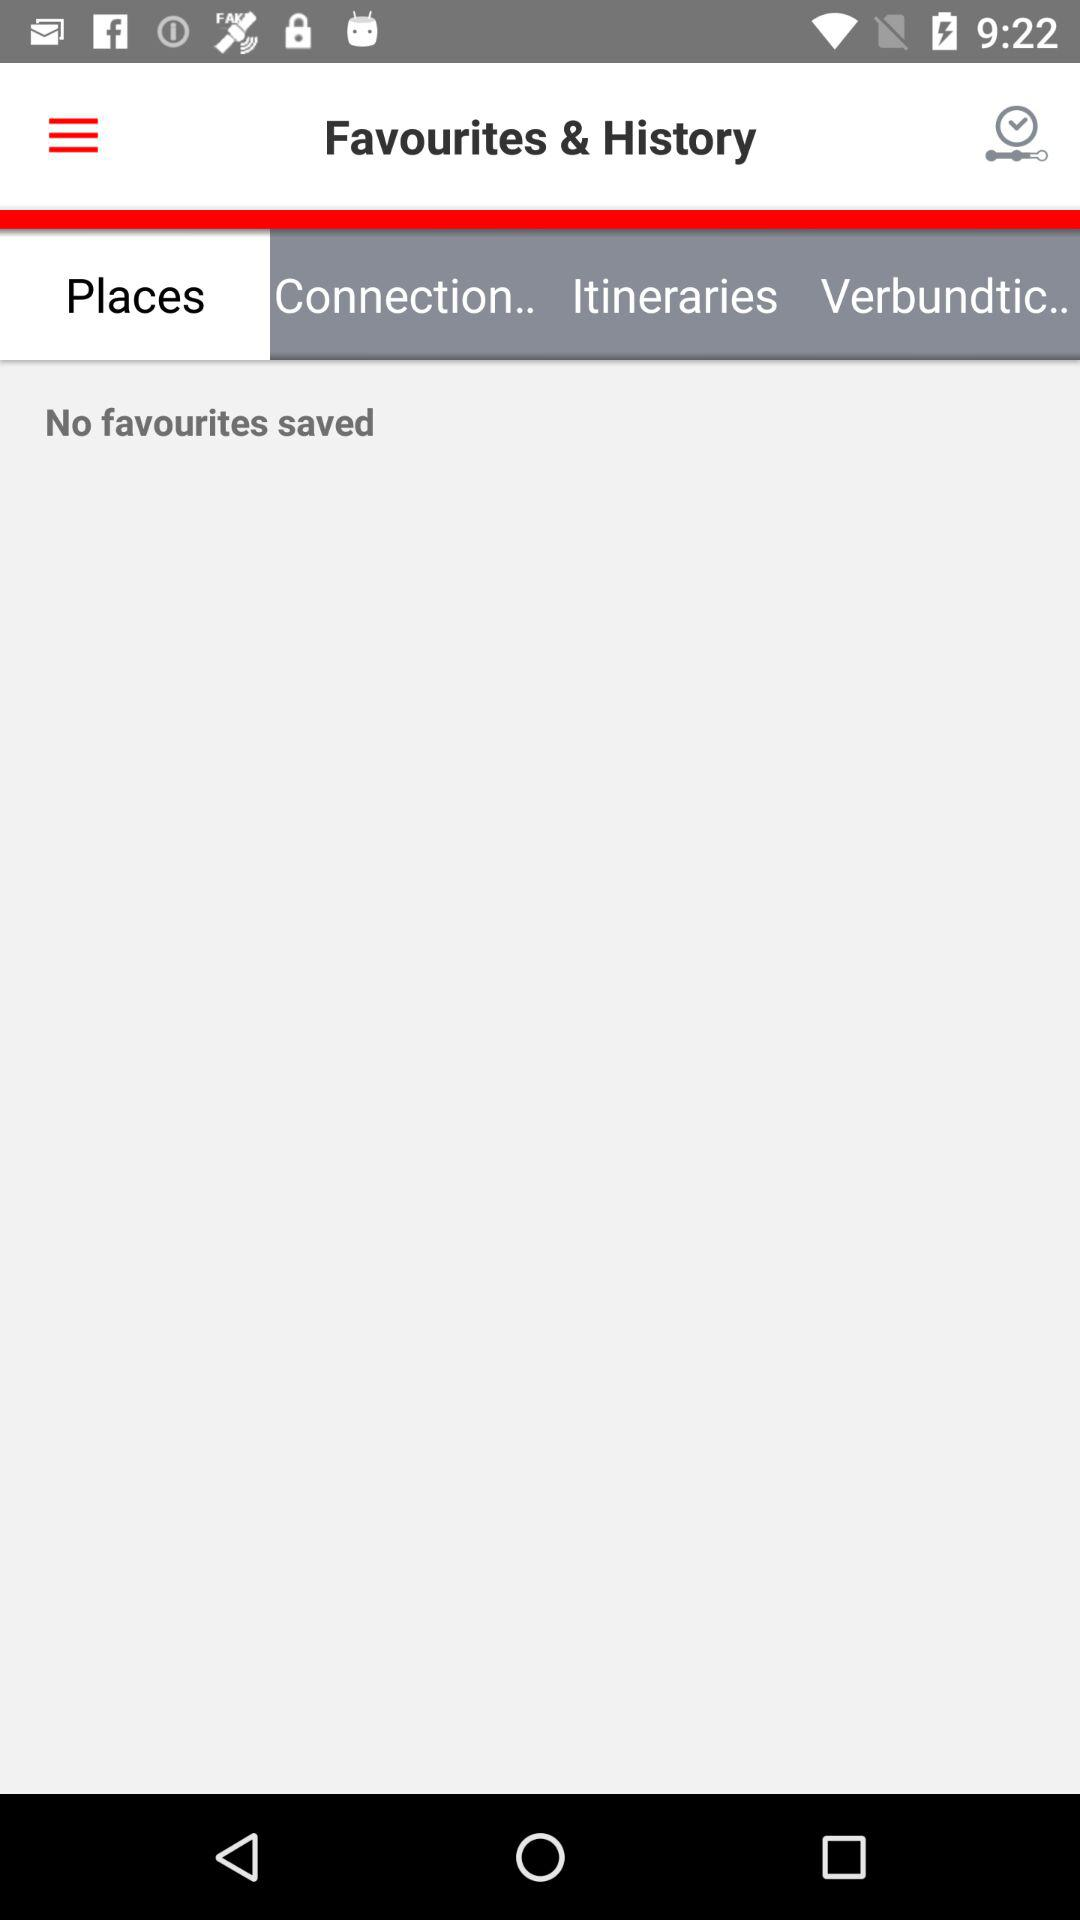Which tab is selected? The selected tab is "Places". 